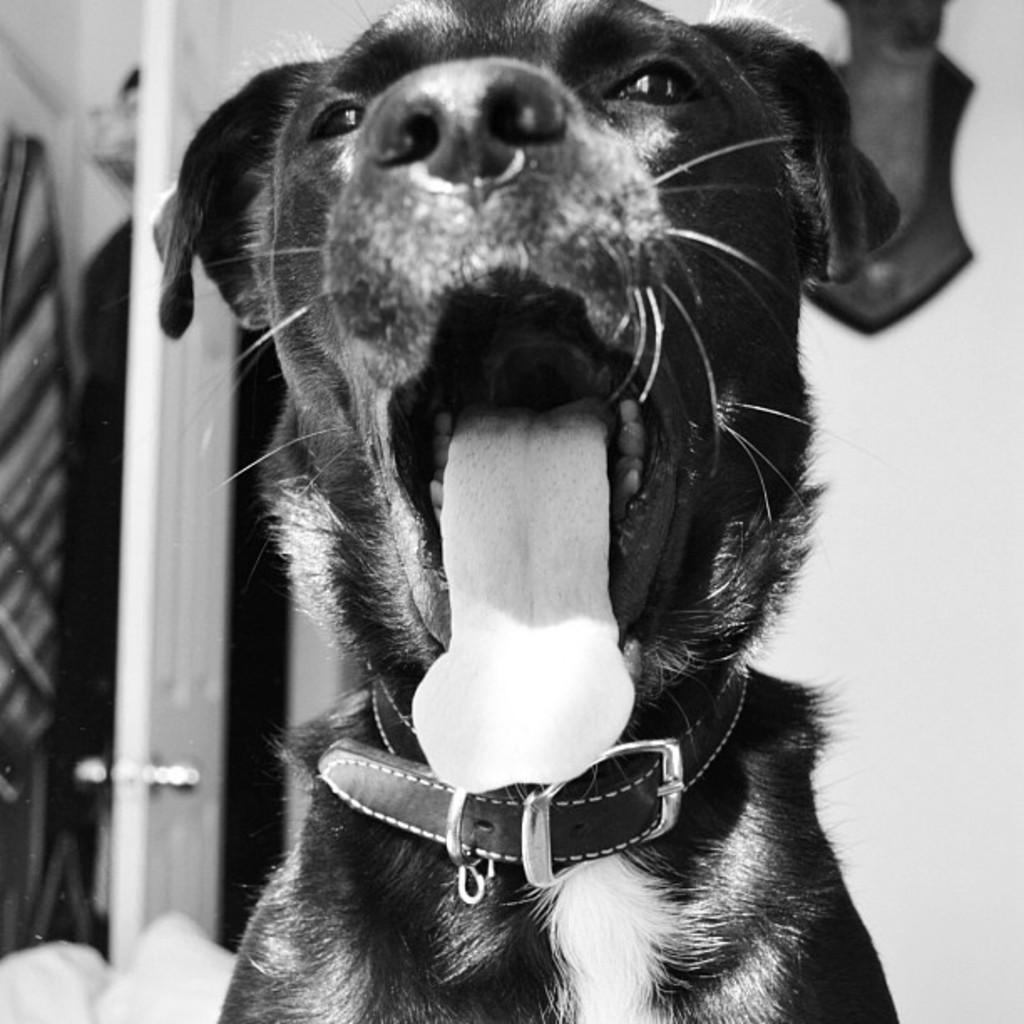What type of animal is in the image? There is a dog in the image. What can be seen in the background of the image? There is a wall and a door in the background of the image. What else is visible in the background of the image? There are clothes in the background of the image. What type of ocean can be seen in the image? There is no ocean present in the image. What day of the week is depicted in the image? The image does not depict a specific day of the week. 